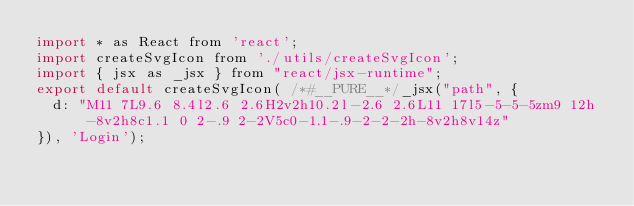<code> <loc_0><loc_0><loc_500><loc_500><_JavaScript_>import * as React from 'react';
import createSvgIcon from './utils/createSvgIcon';
import { jsx as _jsx } from "react/jsx-runtime";
export default createSvgIcon( /*#__PURE__*/_jsx("path", {
  d: "M11 7L9.6 8.4l2.6 2.6H2v2h10.2l-2.6 2.6L11 17l5-5-5-5zm9 12h-8v2h8c1.1 0 2-.9 2-2V5c0-1.1-.9-2-2-2h-8v2h8v14z"
}), 'Login');</code> 